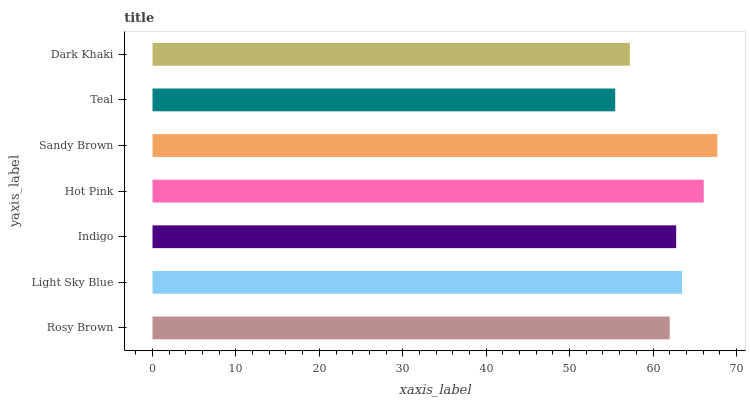Is Teal the minimum?
Answer yes or no. Yes. Is Sandy Brown the maximum?
Answer yes or no. Yes. Is Light Sky Blue the minimum?
Answer yes or no. No. Is Light Sky Blue the maximum?
Answer yes or no. No. Is Light Sky Blue greater than Rosy Brown?
Answer yes or no. Yes. Is Rosy Brown less than Light Sky Blue?
Answer yes or no. Yes. Is Rosy Brown greater than Light Sky Blue?
Answer yes or no. No. Is Light Sky Blue less than Rosy Brown?
Answer yes or no. No. Is Indigo the high median?
Answer yes or no. Yes. Is Indigo the low median?
Answer yes or no. Yes. Is Rosy Brown the high median?
Answer yes or no. No. Is Dark Khaki the low median?
Answer yes or no. No. 